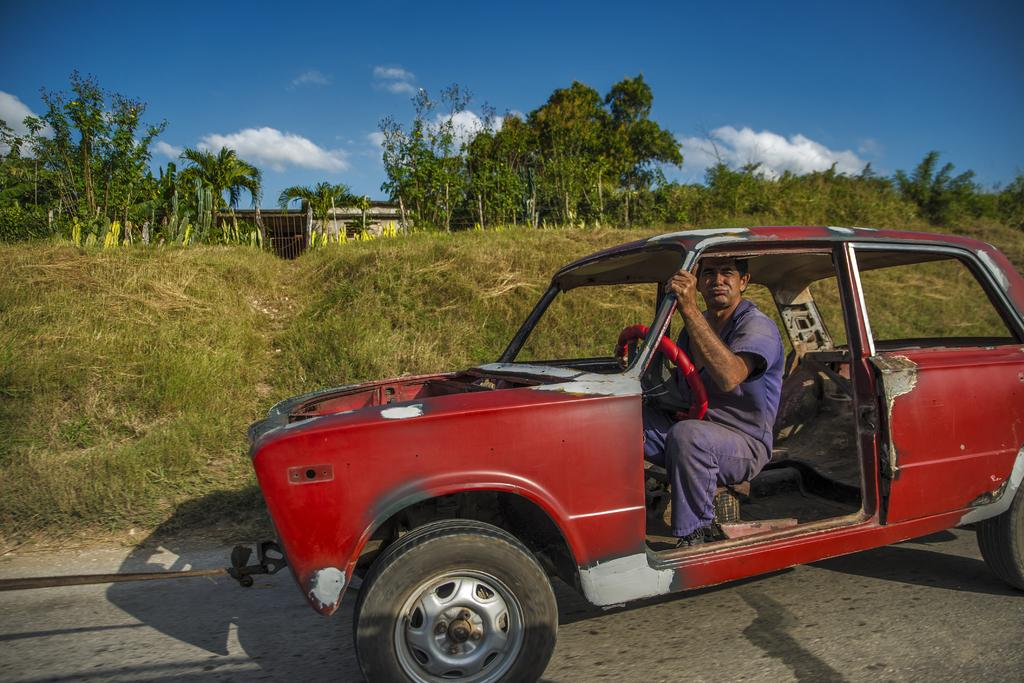What is the man in the image doing? The man is sitting in a car. What can be seen in the background of the image? There are trees and clouds in the background of the image. What part of the natural environment is visible in the image? The sky is visible in the background of the image. What type of milk is the man drinking in the image? There is no milk present in the image; the man is sitting in a car. How does the man stretch in the image? The man is not stretching in the image; he is sitting in a car. 